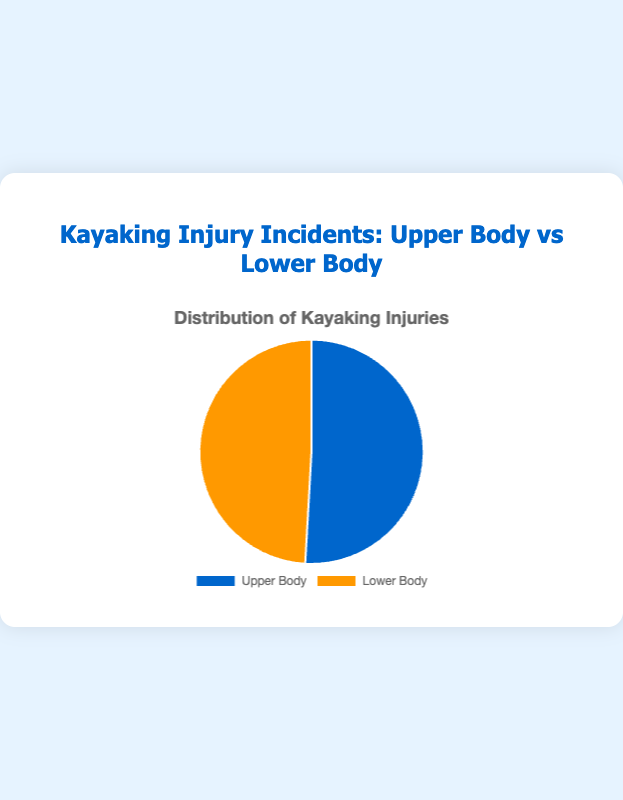Which injury type, Upper Body or Lower Body, has a higher incident count based on the pie chart? By observing the pie chart, we see that the slice representing Upper Body injuries is slightly larger than the slice for Lower Body injuries. Therefore, Upper Body injuries have a higher incident count.
Answer: Upper Body What is the total number of injury incidents represented in the pie chart? To find the total number of incidents, sum the counts of both Upper Body and Lower Body injuries: 57 (Upper Body) + 55 (Lower Body) = 112.
Answer: 112 How much more frequent are Upper Body injuries compared to Lower Body injuries? Subtract the number of Lower Body injuries from the number of Upper Body injuries: 57 (Upper Body) - 55 (Lower Body) = 2.
Answer: 2 What percentage of the total injuries are Upper Body injuries? Calculate the percentage by dividing the Upper Body incident count by the total incidents and multiplying by 100: (57 / 112) * 100 ≈ 50.9%.
Answer: 50.9% If another injury type is introduced with 8 incidents, how would the percentages change for Upper Body and Lower Body injuries? Calculate the new total count: 57 + 55 + 8 = 120. Calculate the new percentages: Upper Body (57 / 120) * 100 = 47.5%, and Lower Body (55 / 120) * 100 ≈ 45.8%.
Answer: Upper Body - 47.5%, Lower Body - 45.8% Which color represents Lower Body injuries in the pie chart? The pie chart has two distinct colors, with Lower Body injuries represented by an orange slice.
Answer: Orange By how much do the Lower Body injuries in the pie chart differ from the Upper Body injuries? The difference in the number of incidents between Upper Body and Lower Body injuries is calculated as follows: 57 (Upper Body) - 55 (Lower Body) = 2.
Answer: 2 What is the ratio of Upper Body injuries to the total number of injuries? The ratio is found by dividing the number of Upper Body injuries by the total number of injuries: 57 / 112 = 0.51.
Answer: 0.51 Which category forms nearly half of the injury incidents? By looking at the pie chart, we can see that both categories form nearly half of the total injury incidents, as the numbers are close: Upper Body (50.9%) and Lower Body (49.1%).
Answer: Both 